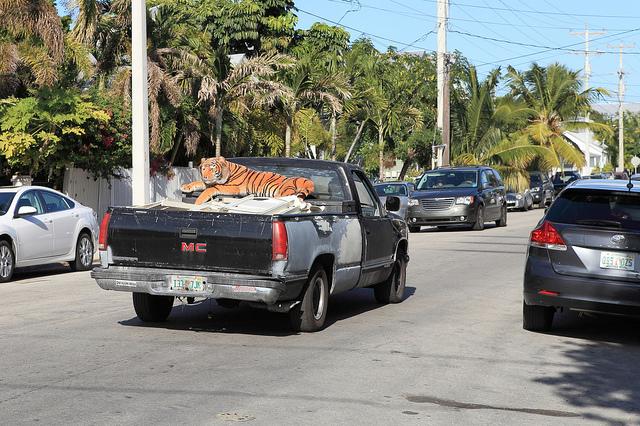Is that Tiger real?
Short answer required. No. What kind of trees line the street?
Answer briefly. Palm. Could this be in a tropical country?
Give a very brief answer. Yes. How many tires are visible in the image?
Give a very brief answer. 9. 